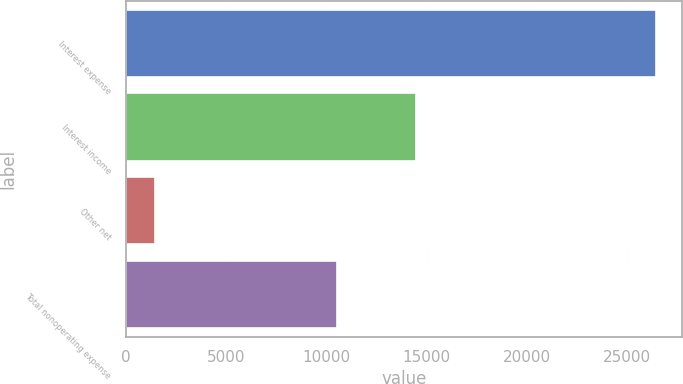Convert chart. <chart><loc_0><loc_0><loc_500><loc_500><bar_chart><fcel>Interest expense<fcel>Interest income<fcel>Other net<fcel>Total nonoperating expense<nl><fcel>26422<fcel>14448<fcel>1459<fcel>10515<nl></chart> 